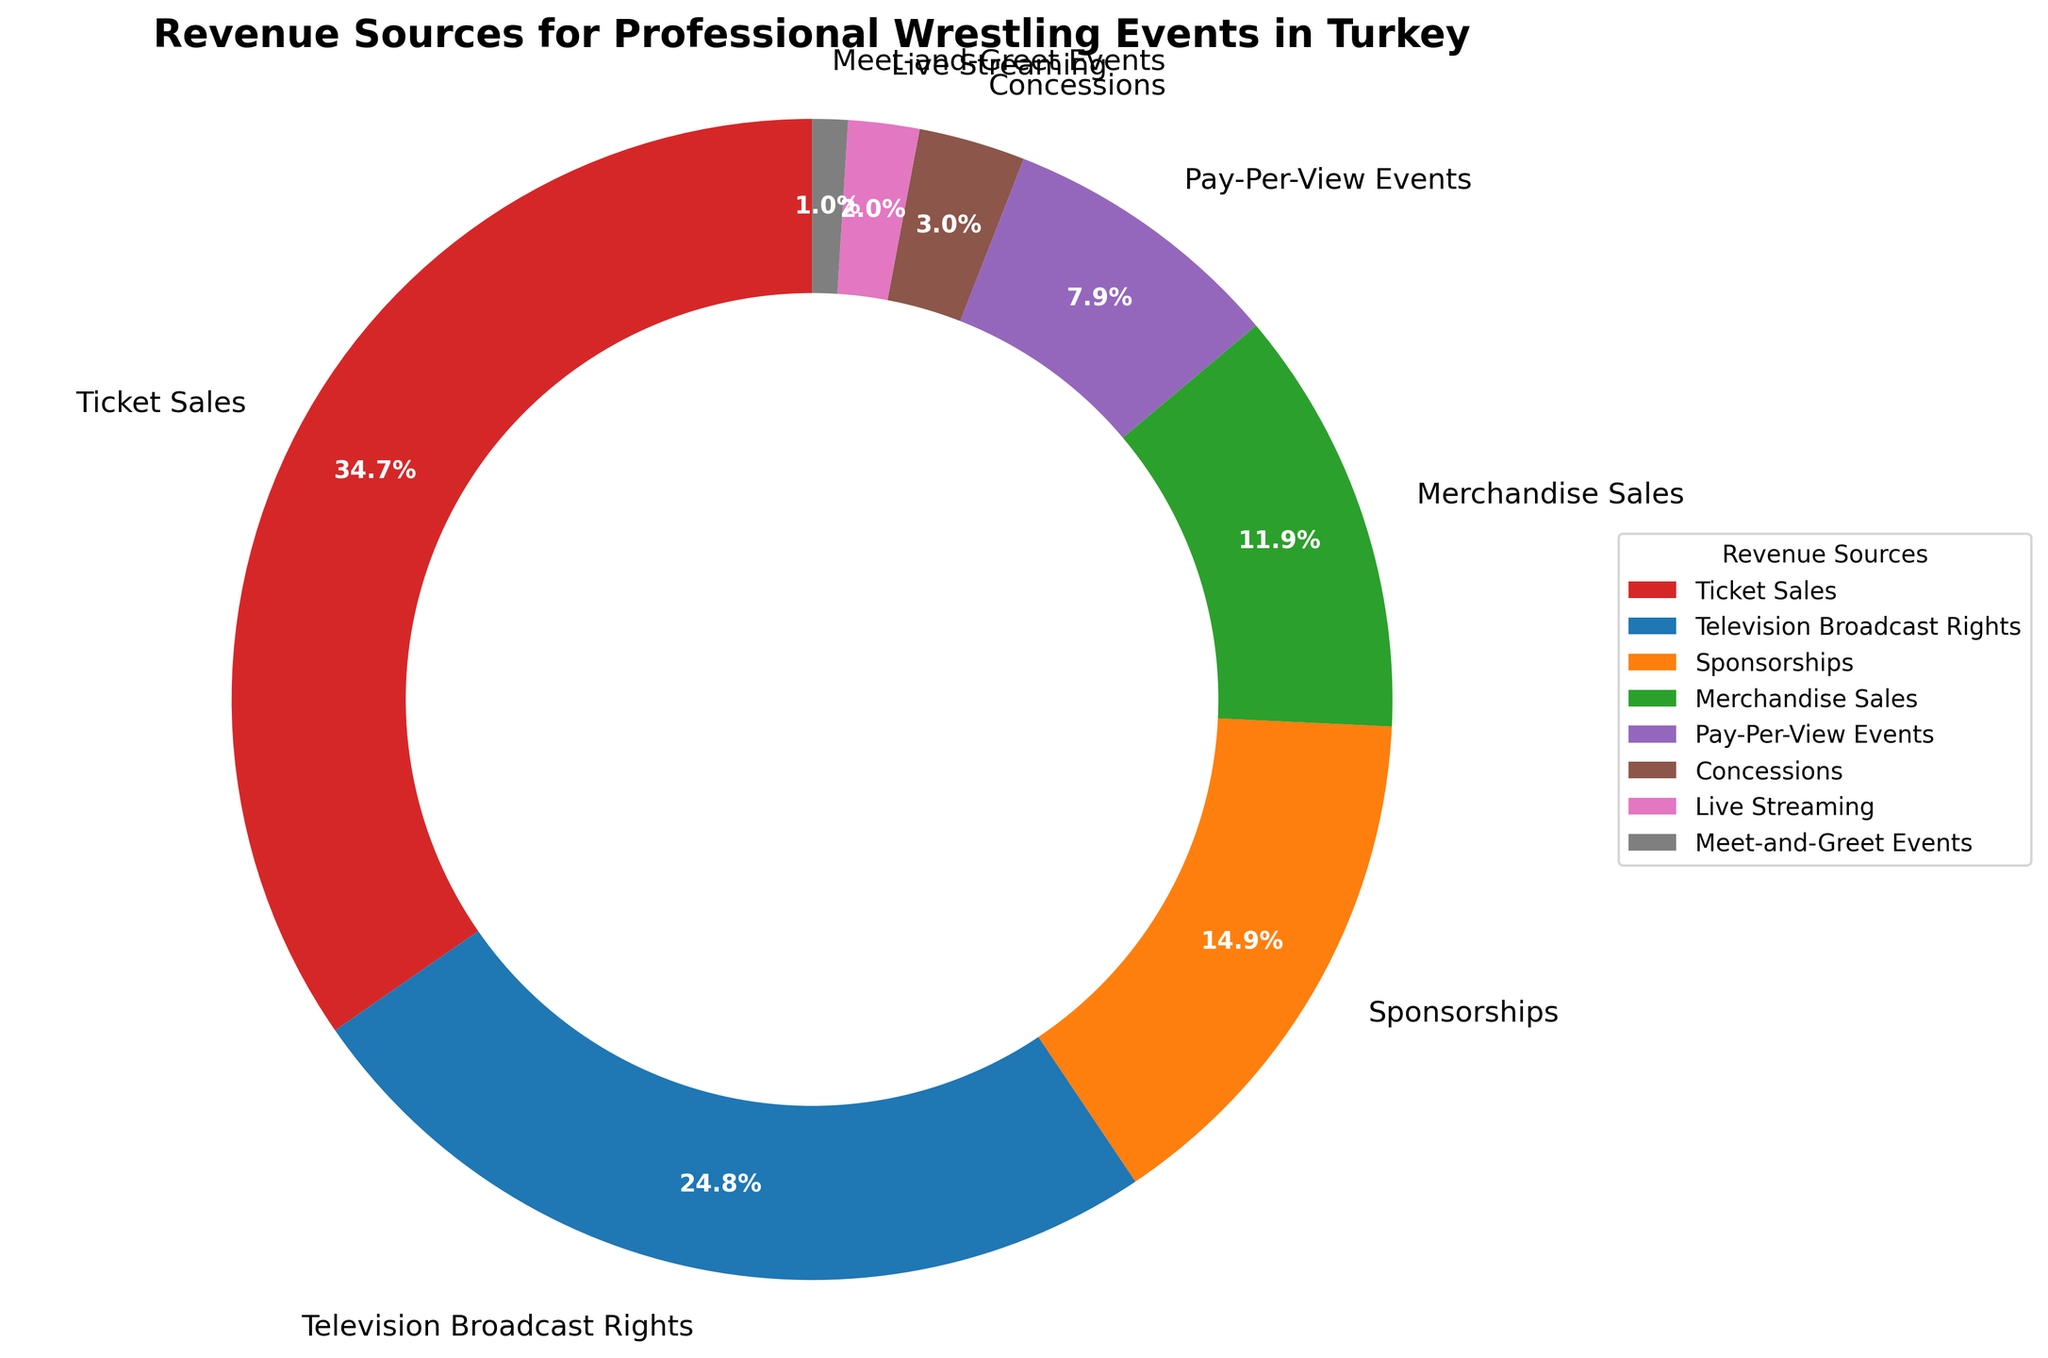Which revenue source contributes the most to wrestling events in Turkey? The pie chart shows the largest segment, which represents Ticket Sales. This segment is noticeably larger than the others, indicating it has the highest percentage.
Answer: Ticket Sales Which revenue source is smaller than Merchandise Sales but larger than Concessions? In the pie chart, Merchandise Sales is indicated with 12%, and the next two segments in decreasing order are Pay-Per-View Events (8%) and Concessions (3%). Thus, Pay-Per-View Events fits this description.
Answer: Pay-Per-View Events What is the combined percentage of Sponsorships and Pay-Per-View Events? According to the pie chart, Sponsorships constitute 15% and Pay-Per-View Events make up 8%. Add these together: 15% + 8% = 23%.
Answer: 23% Compare the size of the Television Broadcast Rights segment to the Ticket Sales segment. The Ticket Sales segment is 35%, while Television Broadcast Rights is 25%. Since 35% is greater than 25%, Ticket Sales is a larger revenue source.
Answer: Ticket Sales is greater What percentage of the revenue comes from sources that each contributes less than 5%? From the pie chart, Concessions (3%), Live Streaming (2%), and Meet-and-Greet Events (1%) each contribute less than 5%. Adding these gives: 3% + 2% + 1% = 6%.
Answer: 6% Which revenue source is represented by the smallest segment on the pie chart? The smallest segment in the pie chart is only 1%, which corresponds to Meet-and-Greet Events.
Answer: Meet-and-Greet Events How much more does Merchandise Sales contribute to the revenue compared to Concessions? Merchandise Sales contribute 12%, while Concessions contribute 3%. Subtracting the percentages gives: 12% - 3% = 9%.
Answer: 9% How many revenue sources contribute more than 10% each? The pie chart shows that Ticket Sales (35%), Television Broadcast Rights (25%), and Sponsorships (15%) all contribute more than 10%. This counts up to three sources.
Answer: 3 What is the visual attribute used to differentiate the sections in the pie chart? The pie chart uses different colors to differentiate the sections, enhancing the visual contrast between segments.
Answer: Different colors Which two revenue sources combined make up 50% of the revenue? Observing the pie chart, Ticket Sales contribute 35% and Television Broadcast Rights add 25%. Adding these together: 35% + 25% = 50%.
Answer: Ticket Sales and Television Broadcast Rights 